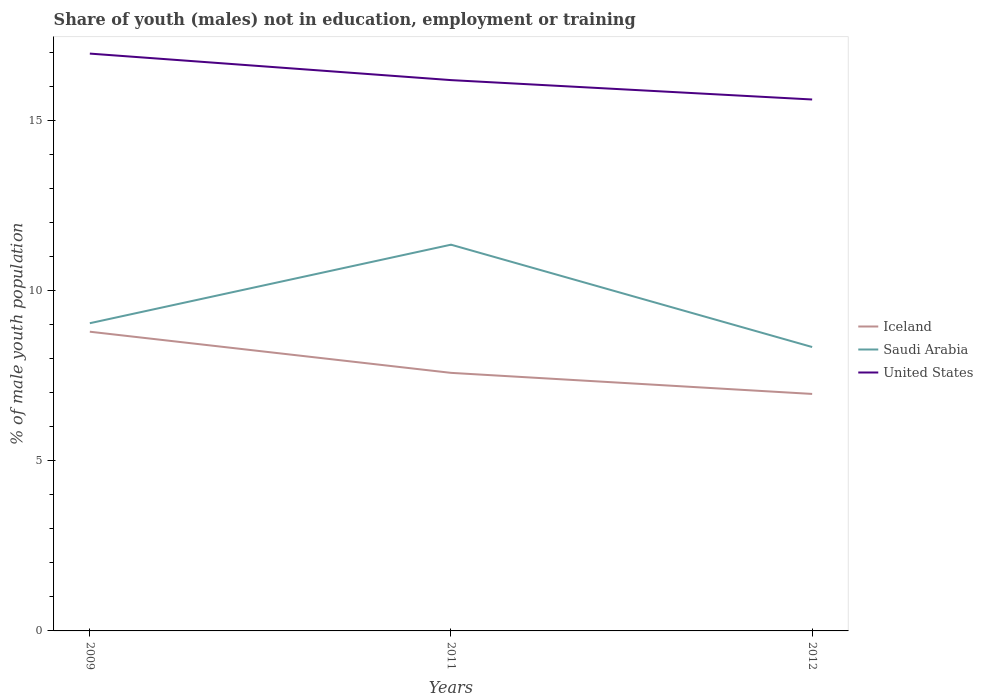How many different coloured lines are there?
Offer a very short reply. 3. Across all years, what is the maximum percentage of unemployed males population in in Saudi Arabia?
Provide a short and direct response. 8.35. In which year was the percentage of unemployed males population in in United States maximum?
Make the answer very short. 2012. What is the total percentage of unemployed males population in in United States in the graph?
Your answer should be very brief. 1.35. What is the difference between the highest and the second highest percentage of unemployed males population in in Iceland?
Offer a terse response. 1.83. How many years are there in the graph?
Your answer should be compact. 3. Does the graph contain any zero values?
Offer a terse response. No. How many legend labels are there?
Your response must be concise. 3. What is the title of the graph?
Your answer should be compact. Share of youth (males) not in education, employment or training. What is the label or title of the Y-axis?
Provide a succinct answer. % of male youth population. What is the % of male youth population of Iceland in 2009?
Provide a succinct answer. 8.8. What is the % of male youth population of Saudi Arabia in 2009?
Your answer should be very brief. 9.05. What is the % of male youth population in United States in 2009?
Provide a succinct answer. 16.98. What is the % of male youth population of Iceland in 2011?
Make the answer very short. 7.59. What is the % of male youth population in Saudi Arabia in 2011?
Your answer should be very brief. 11.36. What is the % of male youth population in United States in 2011?
Offer a very short reply. 16.2. What is the % of male youth population of Iceland in 2012?
Offer a terse response. 6.97. What is the % of male youth population in Saudi Arabia in 2012?
Provide a short and direct response. 8.35. What is the % of male youth population in United States in 2012?
Offer a terse response. 15.63. Across all years, what is the maximum % of male youth population of Iceland?
Keep it short and to the point. 8.8. Across all years, what is the maximum % of male youth population of Saudi Arabia?
Provide a succinct answer. 11.36. Across all years, what is the maximum % of male youth population in United States?
Keep it short and to the point. 16.98. Across all years, what is the minimum % of male youth population of Iceland?
Your answer should be compact. 6.97. Across all years, what is the minimum % of male youth population of Saudi Arabia?
Make the answer very short. 8.35. Across all years, what is the minimum % of male youth population of United States?
Your answer should be compact. 15.63. What is the total % of male youth population in Iceland in the graph?
Ensure brevity in your answer.  23.36. What is the total % of male youth population in Saudi Arabia in the graph?
Your response must be concise. 28.76. What is the total % of male youth population in United States in the graph?
Your response must be concise. 48.81. What is the difference between the % of male youth population of Iceland in 2009 and that in 2011?
Provide a succinct answer. 1.21. What is the difference between the % of male youth population of Saudi Arabia in 2009 and that in 2011?
Offer a terse response. -2.31. What is the difference between the % of male youth population in United States in 2009 and that in 2011?
Keep it short and to the point. 0.78. What is the difference between the % of male youth population in Iceland in 2009 and that in 2012?
Your response must be concise. 1.83. What is the difference between the % of male youth population of United States in 2009 and that in 2012?
Ensure brevity in your answer.  1.35. What is the difference between the % of male youth population of Iceland in 2011 and that in 2012?
Offer a terse response. 0.62. What is the difference between the % of male youth population of Saudi Arabia in 2011 and that in 2012?
Provide a succinct answer. 3.01. What is the difference between the % of male youth population in United States in 2011 and that in 2012?
Provide a short and direct response. 0.57. What is the difference between the % of male youth population of Iceland in 2009 and the % of male youth population of Saudi Arabia in 2011?
Ensure brevity in your answer.  -2.56. What is the difference between the % of male youth population in Saudi Arabia in 2009 and the % of male youth population in United States in 2011?
Give a very brief answer. -7.15. What is the difference between the % of male youth population of Iceland in 2009 and the % of male youth population of Saudi Arabia in 2012?
Provide a short and direct response. 0.45. What is the difference between the % of male youth population of Iceland in 2009 and the % of male youth population of United States in 2012?
Your answer should be very brief. -6.83. What is the difference between the % of male youth population in Saudi Arabia in 2009 and the % of male youth population in United States in 2012?
Give a very brief answer. -6.58. What is the difference between the % of male youth population of Iceland in 2011 and the % of male youth population of Saudi Arabia in 2012?
Provide a short and direct response. -0.76. What is the difference between the % of male youth population in Iceland in 2011 and the % of male youth population in United States in 2012?
Make the answer very short. -8.04. What is the difference between the % of male youth population in Saudi Arabia in 2011 and the % of male youth population in United States in 2012?
Your answer should be compact. -4.27. What is the average % of male youth population of Iceland per year?
Give a very brief answer. 7.79. What is the average % of male youth population of Saudi Arabia per year?
Your answer should be compact. 9.59. What is the average % of male youth population in United States per year?
Your answer should be very brief. 16.27. In the year 2009, what is the difference between the % of male youth population of Iceland and % of male youth population of United States?
Your response must be concise. -8.18. In the year 2009, what is the difference between the % of male youth population in Saudi Arabia and % of male youth population in United States?
Your answer should be very brief. -7.93. In the year 2011, what is the difference between the % of male youth population in Iceland and % of male youth population in Saudi Arabia?
Make the answer very short. -3.77. In the year 2011, what is the difference between the % of male youth population of Iceland and % of male youth population of United States?
Provide a succinct answer. -8.61. In the year 2011, what is the difference between the % of male youth population of Saudi Arabia and % of male youth population of United States?
Your answer should be very brief. -4.84. In the year 2012, what is the difference between the % of male youth population in Iceland and % of male youth population in Saudi Arabia?
Offer a very short reply. -1.38. In the year 2012, what is the difference between the % of male youth population of Iceland and % of male youth population of United States?
Give a very brief answer. -8.66. In the year 2012, what is the difference between the % of male youth population of Saudi Arabia and % of male youth population of United States?
Your answer should be very brief. -7.28. What is the ratio of the % of male youth population of Iceland in 2009 to that in 2011?
Keep it short and to the point. 1.16. What is the ratio of the % of male youth population in Saudi Arabia in 2009 to that in 2011?
Ensure brevity in your answer.  0.8. What is the ratio of the % of male youth population of United States in 2009 to that in 2011?
Your response must be concise. 1.05. What is the ratio of the % of male youth population in Iceland in 2009 to that in 2012?
Give a very brief answer. 1.26. What is the ratio of the % of male youth population in Saudi Arabia in 2009 to that in 2012?
Your answer should be very brief. 1.08. What is the ratio of the % of male youth population of United States in 2009 to that in 2012?
Your response must be concise. 1.09. What is the ratio of the % of male youth population of Iceland in 2011 to that in 2012?
Offer a terse response. 1.09. What is the ratio of the % of male youth population of Saudi Arabia in 2011 to that in 2012?
Your response must be concise. 1.36. What is the ratio of the % of male youth population in United States in 2011 to that in 2012?
Ensure brevity in your answer.  1.04. What is the difference between the highest and the second highest % of male youth population of Iceland?
Offer a terse response. 1.21. What is the difference between the highest and the second highest % of male youth population in Saudi Arabia?
Your response must be concise. 2.31. What is the difference between the highest and the second highest % of male youth population in United States?
Make the answer very short. 0.78. What is the difference between the highest and the lowest % of male youth population of Iceland?
Provide a succinct answer. 1.83. What is the difference between the highest and the lowest % of male youth population of Saudi Arabia?
Ensure brevity in your answer.  3.01. What is the difference between the highest and the lowest % of male youth population in United States?
Make the answer very short. 1.35. 